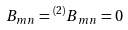Convert formula to latex. <formula><loc_0><loc_0><loc_500><loc_500>B _ { m n } = { ^ { ( 2 ) } B } _ { m n } = 0</formula> 